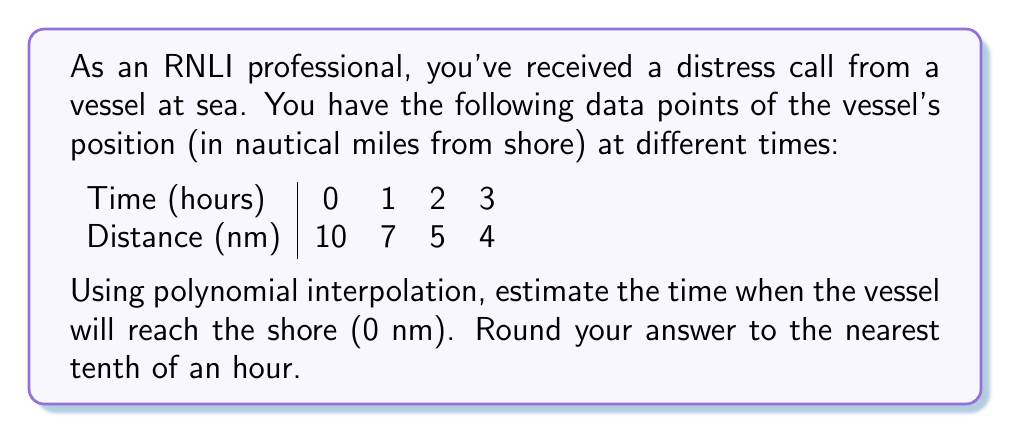Show me your answer to this math problem. To solve this problem, we'll use Lagrange polynomial interpolation:

1) The Lagrange interpolation polynomial is given by:
   $$P(x) = \sum_{i=0}^n y_i \cdot L_i(x)$$
   where $L_i(x) = \prod_{j=0, j \neq i}^n \frac{x - x_j}{x_i - x_j}$

2) In our case, we have:
   $(x_0, y_0) = (0, 10)$, $(x_1, y_1) = (1, 7)$, $(x_2, y_2) = (2, 5)$, $(x_3, y_3) = (4, 4)$

3) Calculate the Lagrange basis polynomials:
   $$L_0(x) = \frac{(x-1)(x-2)(x-3)}{(0-1)(0-2)(0-3)} = -\frac{1}{6}(x-1)(x-2)(x-3)$$
   $$L_1(x) = \frac{(x-0)(x-2)(x-3)}{(1-0)(1-2)(1-3)} = \frac{1}{2}x(x-2)(x-3)$$
   $$L_2(x) = \frac{(x-0)(x-1)(x-3)}{(2-0)(2-1)(2-3)} = -\frac{1}{2}x(x-1)(x-3)$$
   $$L_3(x) = \frac{(x-0)(x-1)(x-2)}{(3-0)(3-1)(3-2)} = \frac{1}{6}x(x-1)(x-2)$$

4) Construct the interpolation polynomial:
   $$P(x) = 10 \cdot (-\frac{1}{6}(x-1)(x-2)(x-3)) + 7 \cdot (\frac{1}{2}x(x-2)(x-3)) + 5 \cdot (-\frac{1}{2}x(x-1)(x-3)) + 4 \cdot (\frac{1}{6}x(x-1)(x-2))$$

5) Simplify:
   $$P(x) = 10 - \frac{11}{3}x + \frac{3}{2}x^2 - \frac{1}{6}x^3$$

6) To find when the vessel reaches shore, solve $P(x) = 0$:
   $$10 - \frac{11}{3}x + \frac{3}{2}x^2 - \frac{1}{6}x^3 = 0$$

7) This cubic equation doesn't have a simple analytical solution. We can solve it numerically or use a graphing calculator to find that $x \approx 4.7$

8) Rounding to the nearest tenth: 4.7 hours
Answer: 4.7 hours 